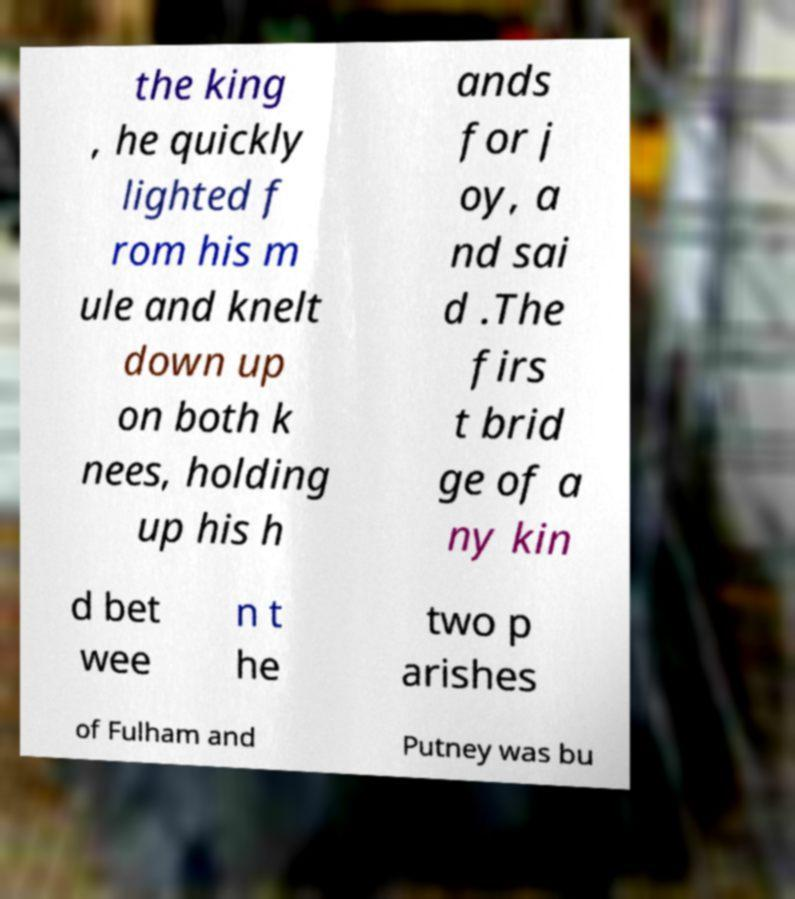Can you accurately transcribe the text from the provided image for me? the king , he quickly lighted f rom his m ule and knelt down up on both k nees, holding up his h ands for j oy, a nd sai d .The firs t brid ge of a ny kin d bet wee n t he two p arishes of Fulham and Putney was bu 